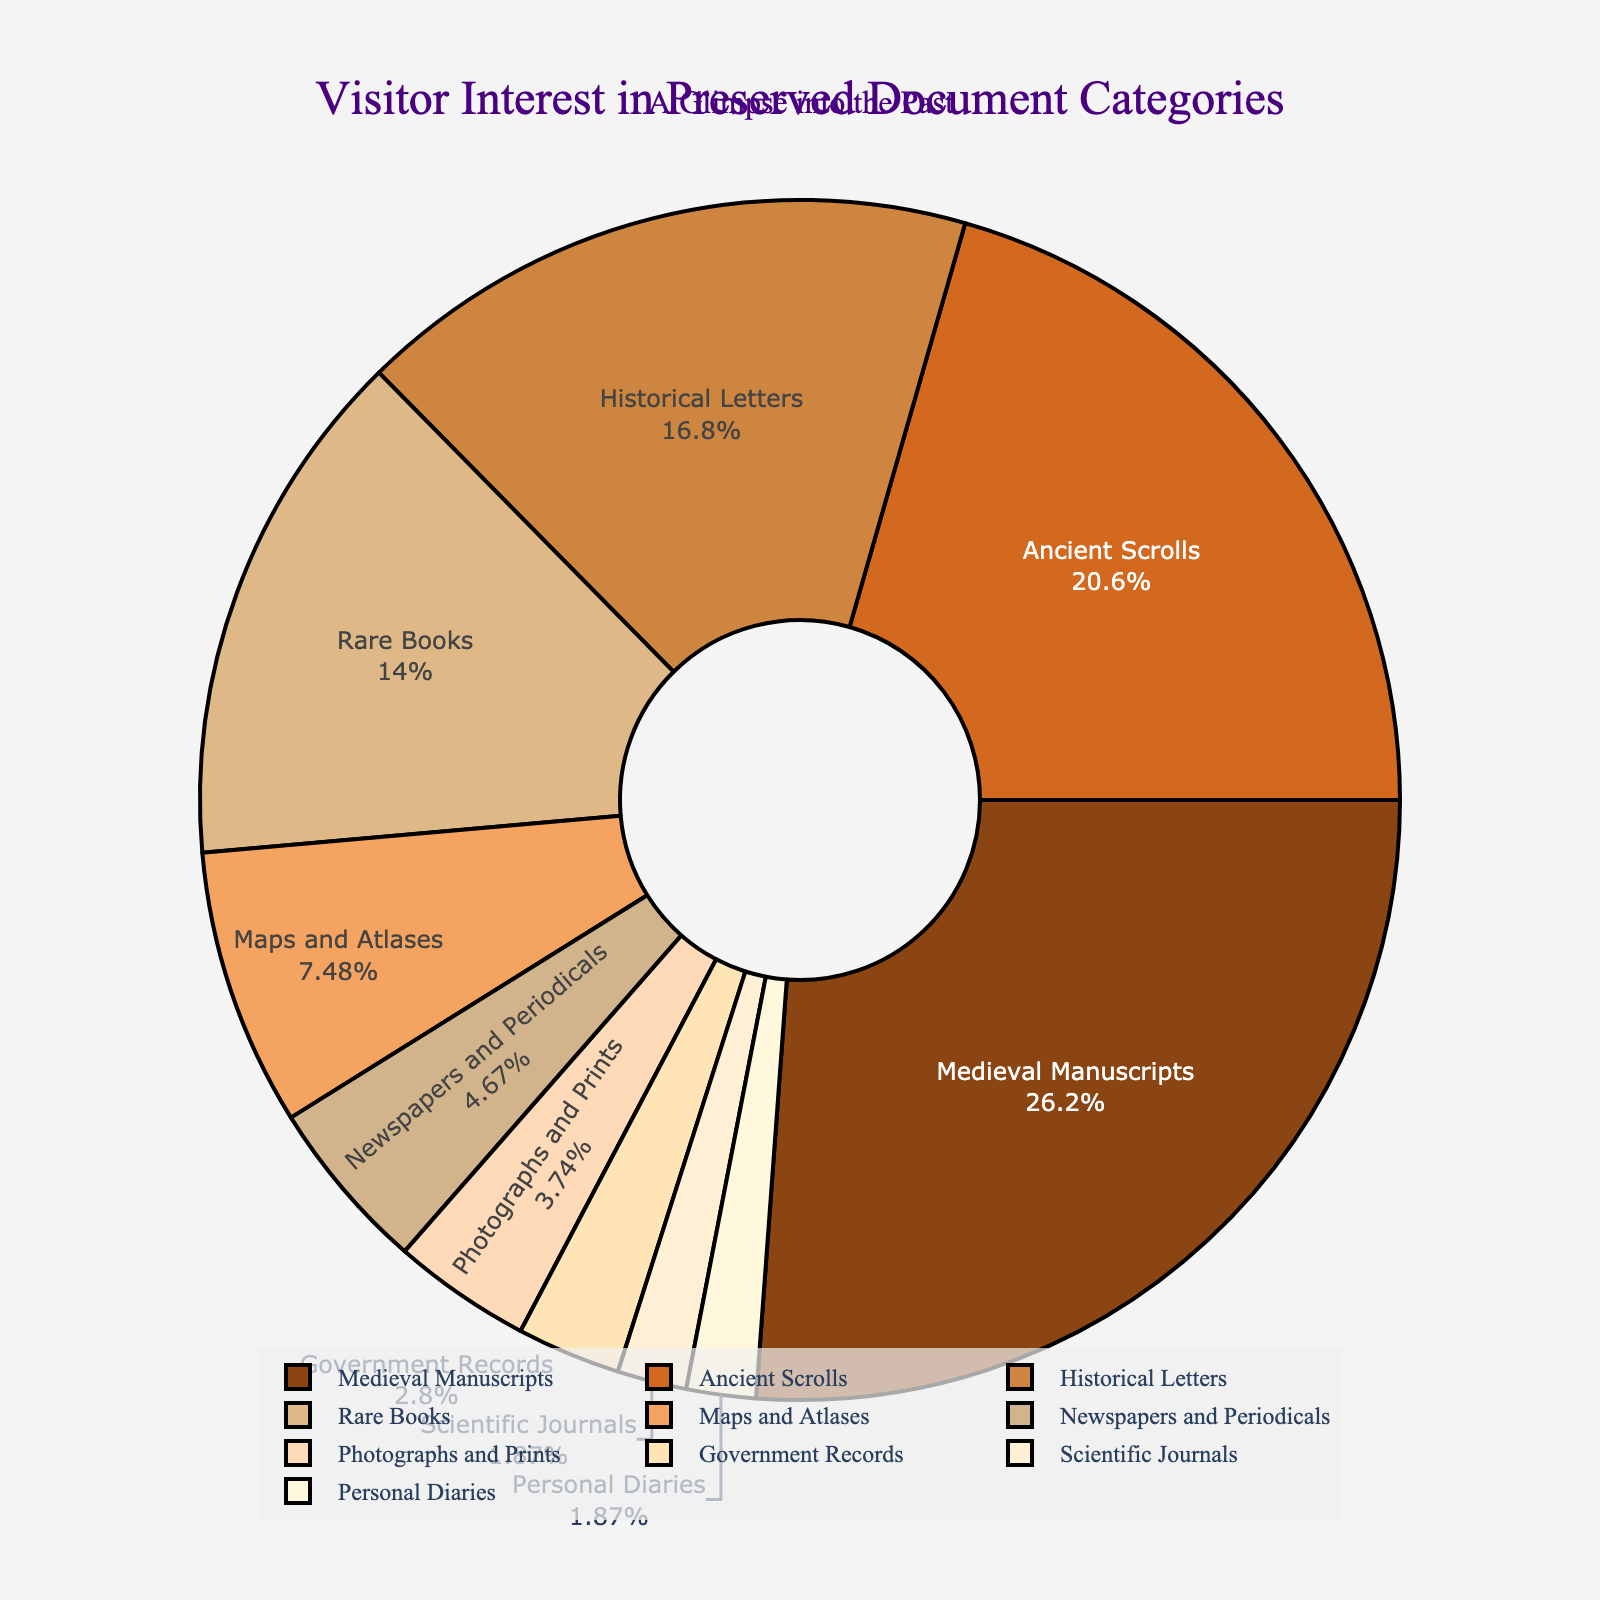How many categories have a visitor interest percentage of 5% or less? First, identify the categories with percentage values of 5% or less: Newspapers and Periodicals (5%), Photographs and Prints (4%), Government Records (3%), Scientific Journals (2%), and Personal Diaries (2%). Count these categories.
Answer: 5 What category has the highest percentage of visitor interest? Identify the category with the highest percentage, which is 28%. The corresponding category is Medieval Manuscripts.
Answer: Medieval Manuscripts What is the total percentage of visitor interest in Ancient Scrolls and Historical Letters combined? Look for the percentages of Ancient Scrolls and Historical Letters, which are 22% and 18%, respectively. Add these percentages together: 22% + 18% = 40%.
Answer: 40% Which categories make up less than 10% of the visitor interest each? Identify categories with percentages less than 10%: Maps and Atlases (8%), Newspapers and Periodicals (5%), Photographs and Prints (4%), Government Records (3%), Scientific Journals (2%), and Personal Diaries (2%). List these categories.
Answer: Maps and Atlases, Newspapers and Periodicals, Photographs and Prints, Government Records, Scientific Journals, Personal Diaries What's the difference in visitor interest percentage between Rare Books and Historical Letters? Find the percentages of Rare Books and Historical Letters, which are 15% and 18%, respectively. Subtract the smaller percentage from the larger one: 18% - 15% = 3%.
Answer: 3% Which category has the smallest visitor interest percentage and what is it? Identify the category with the smallest percentage value, which is 2%. The corresponding categories are Scientific Journals and Personal Diaries.
Answer: Scientific Journals, Personal Diaries What is the cumulative percentage of visitor interest in the top three categories? Identify the top three categories by their percentages: Medieval Manuscripts (28%), Ancient Scrolls (22%), and Historical Letters (18%). Add these together: 28% + 22% + 18% = 68%.
Answer: 68% Are there more categories with visitor interest percentages above or below 10%? Count the categories with percentages above 10% (Medieval Manuscripts, Ancient Scrolls, Historical Letters, Rare Books; total 4) and below 10% (Maps and Atlases, Newspapers and Periodicals, Photographs and Prints, Government Records, Scientific Journals, Personal Diaries; total 6). Compare these counts.
Answer: Below Which category is represented with the color closest to brown in the chart? Visually identify the color closest to brown in the chart and find the corresponding category. The color closest to brown is typically associated with Medieval Manuscripts.
Answer: Medieval Manuscripts What is the average visitor interest percentage for the categories of Newspapers and Periodicals, Photographs and Prints, and Government Records? Identify the percentages for Newspapers and Periodicals (5%), Photographs and Prints (4%), and Government Records (3%). Add these together and divide by 3: (5% + 4% + 3%) / 3 = 4%.
Answer: 4% 